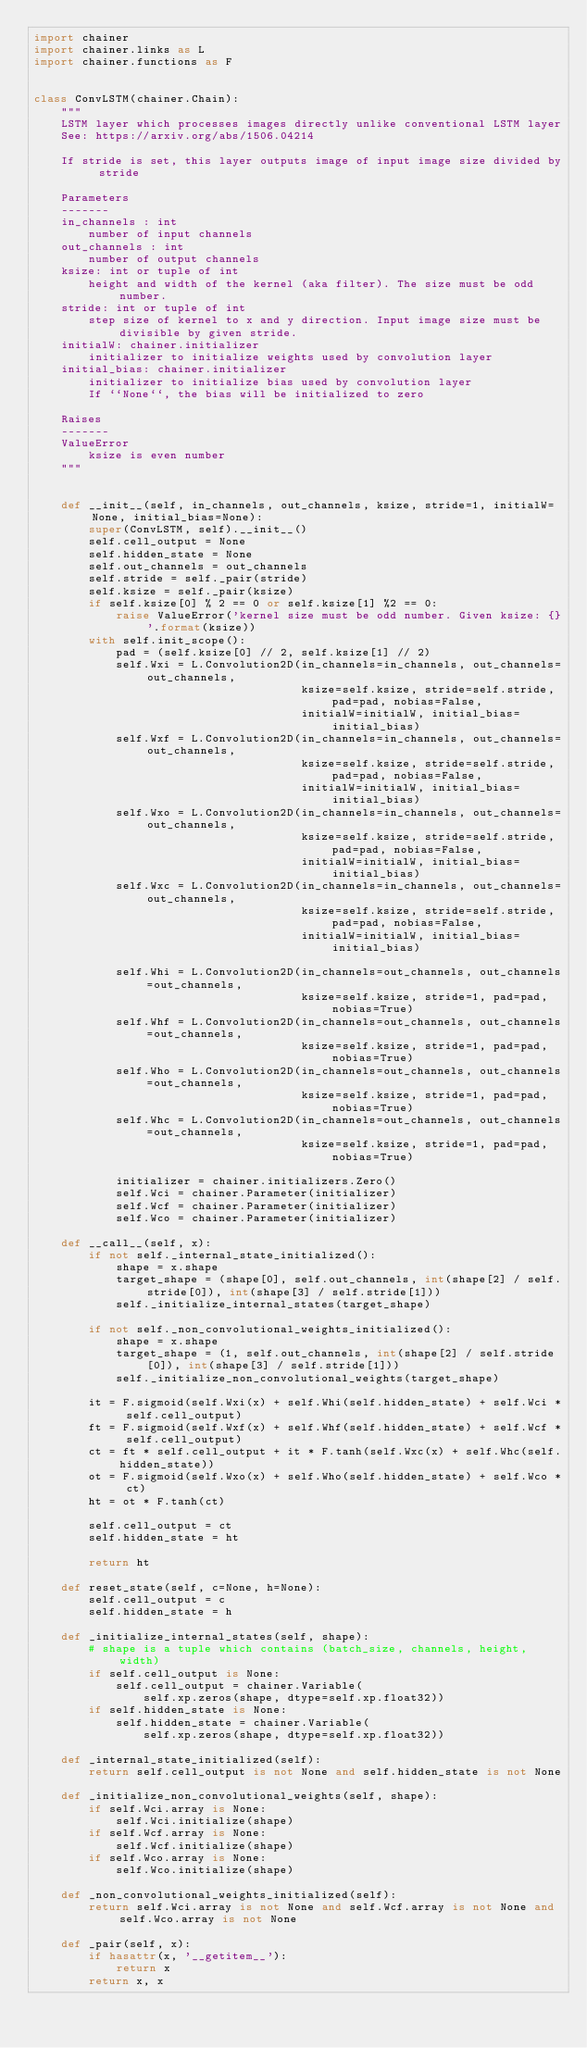<code> <loc_0><loc_0><loc_500><loc_500><_Python_>import chainer
import chainer.links as L
import chainer.functions as F


class ConvLSTM(chainer.Chain):
    """
    LSTM layer which processes images directly unlike conventional LSTM layer
    See: https://arxiv.org/abs/1506.04214

    If stride is set, this layer outputs image of input image size divided by stride

    Parameters
    -------
    in_channels : int
        number of input channels
    out_channels : int 
        number of output channels
    ksize: int or tuple of int
        height and width of the kernel (aka filter). The size must be odd number.
    stride: int or tuple of int
        step size of kernel to x and y direction. Input image size must be divisible by given stride.
    initialW: chainer.initializer
        initializer to initialize weights used by convolution layer
    initial_bias: chainer.initializer
        initializer to initialize bias used by convolution layer
        If ``None``, the bias will be initialized to zero

    Raises
    -------
    ValueError
        ksize is even number
    """


    def __init__(self, in_channels, out_channels, ksize, stride=1, initialW=None, initial_bias=None):
        super(ConvLSTM, self).__init__()
        self.cell_output = None
        self.hidden_state = None
        self.out_channels = out_channels
        self.stride = self._pair(stride)
        self.ksize = self._pair(ksize)
        if self.ksize[0] % 2 == 0 or self.ksize[1] %2 == 0:
            raise ValueError('kernel size must be odd number. Given ksize: {}'.format(ksize))
        with self.init_scope():
            pad = (self.ksize[0] // 2, self.ksize[1] // 2)
            self.Wxi = L.Convolution2D(in_channels=in_channels, out_channels=out_channels,
                                       ksize=self.ksize, stride=self.stride, pad=pad, nobias=False,
                                       initialW=initialW, initial_bias=initial_bias)
            self.Wxf = L.Convolution2D(in_channels=in_channels, out_channels=out_channels,
                                       ksize=self.ksize, stride=self.stride, pad=pad, nobias=False,
                                       initialW=initialW, initial_bias=initial_bias)
            self.Wxo = L.Convolution2D(in_channels=in_channels, out_channels=out_channels,
                                       ksize=self.ksize, stride=self.stride, pad=pad, nobias=False,
                                       initialW=initialW, initial_bias=initial_bias)
            self.Wxc = L.Convolution2D(in_channels=in_channels, out_channels=out_channels,
                                       ksize=self.ksize, stride=self.stride, pad=pad, nobias=False,
                                       initialW=initialW, initial_bias=initial_bias)

            self.Whi = L.Convolution2D(in_channels=out_channels, out_channels=out_channels,
                                       ksize=self.ksize, stride=1, pad=pad, nobias=True)
            self.Whf = L.Convolution2D(in_channels=out_channels, out_channels=out_channels,
                                       ksize=self.ksize, stride=1, pad=pad, nobias=True)
            self.Who = L.Convolution2D(in_channels=out_channels, out_channels=out_channels,
                                       ksize=self.ksize, stride=1, pad=pad, nobias=True)
            self.Whc = L.Convolution2D(in_channels=out_channels, out_channels=out_channels,
                                       ksize=self.ksize, stride=1, pad=pad, nobias=True)

            initializer = chainer.initializers.Zero()
            self.Wci = chainer.Parameter(initializer)
            self.Wcf = chainer.Parameter(initializer)
            self.Wco = chainer.Parameter(initializer)

    def __call__(self, x):
        if not self._internal_state_initialized():
            shape = x.shape
            target_shape = (shape[0], self.out_channels, int(shape[2] / self.stride[0]), int(shape[3] / self.stride[1]))
            self._initialize_internal_states(target_shape)

        if not self._non_convolutional_weights_initialized():
            shape = x.shape
            target_shape = (1, self.out_channels, int(shape[2] / self.stride[0]), int(shape[3] / self.stride[1]))
            self._initialize_non_convolutional_weights(target_shape)

        it = F.sigmoid(self.Wxi(x) + self.Whi(self.hidden_state) + self.Wci * self.cell_output)
        ft = F.sigmoid(self.Wxf(x) + self.Whf(self.hidden_state) + self.Wcf * self.cell_output)
        ct = ft * self.cell_output + it * F.tanh(self.Wxc(x) + self.Whc(self.hidden_state))
        ot = F.sigmoid(self.Wxo(x) + self.Who(self.hidden_state) + self.Wco * ct)
        ht = ot * F.tanh(ct)

        self.cell_output = ct
        self.hidden_state = ht

        return ht

    def reset_state(self, c=None, h=None):
        self.cell_output = c
        self.hidden_state = h

    def _initialize_internal_states(self, shape):
        # shape is a tuple which contains (batch_size, channels, height, width)
        if self.cell_output is None:
            self.cell_output = chainer.Variable(
                self.xp.zeros(shape, dtype=self.xp.float32))
        if self.hidden_state is None:
            self.hidden_state = chainer.Variable(
                self.xp.zeros(shape, dtype=self.xp.float32))

    def _internal_state_initialized(self):
        return self.cell_output is not None and self.hidden_state is not None

    def _initialize_non_convolutional_weights(self, shape):
        if self.Wci.array is None:
            self.Wci.initialize(shape)
        if self.Wcf.array is None:
            self.Wcf.initialize(shape)
        if self.Wco.array is None:
            self.Wco.initialize(shape)

    def _non_convolutional_weights_initialized(self):
        return self.Wci.array is not None and self.Wcf.array is not None and self.Wco.array is not None

    def _pair(self, x):
        if hasattr(x, '__getitem__'):
            return x
        return x, x
</code> 